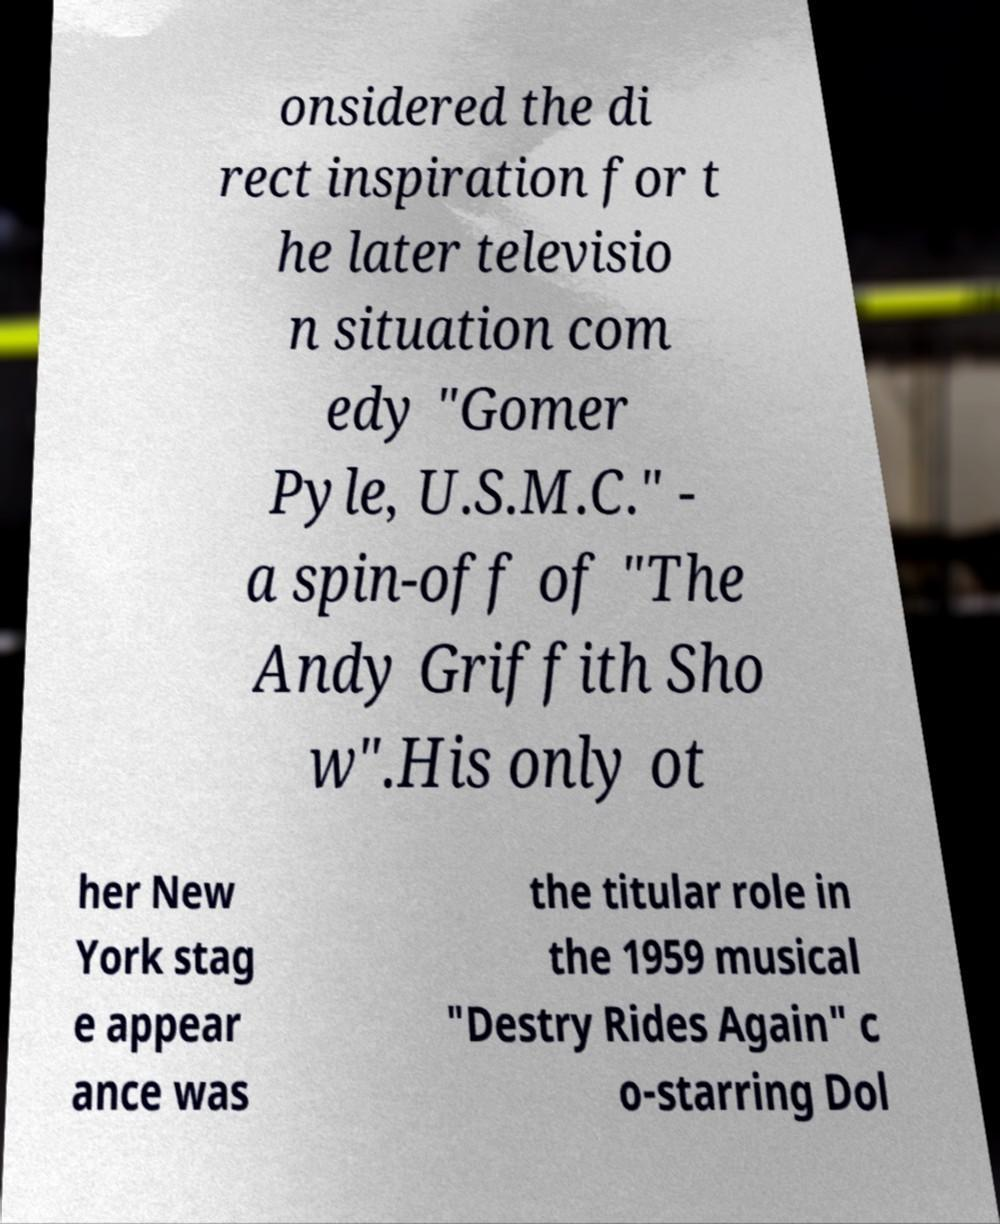For documentation purposes, I need the text within this image transcribed. Could you provide that? onsidered the di rect inspiration for t he later televisio n situation com edy "Gomer Pyle, U.S.M.C." - a spin-off of "The Andy Griffith Sho w".His only ot her New York stag e appear ance was the titular role in the 1959 musical "Destry Rides Again" c o-starring Dol 